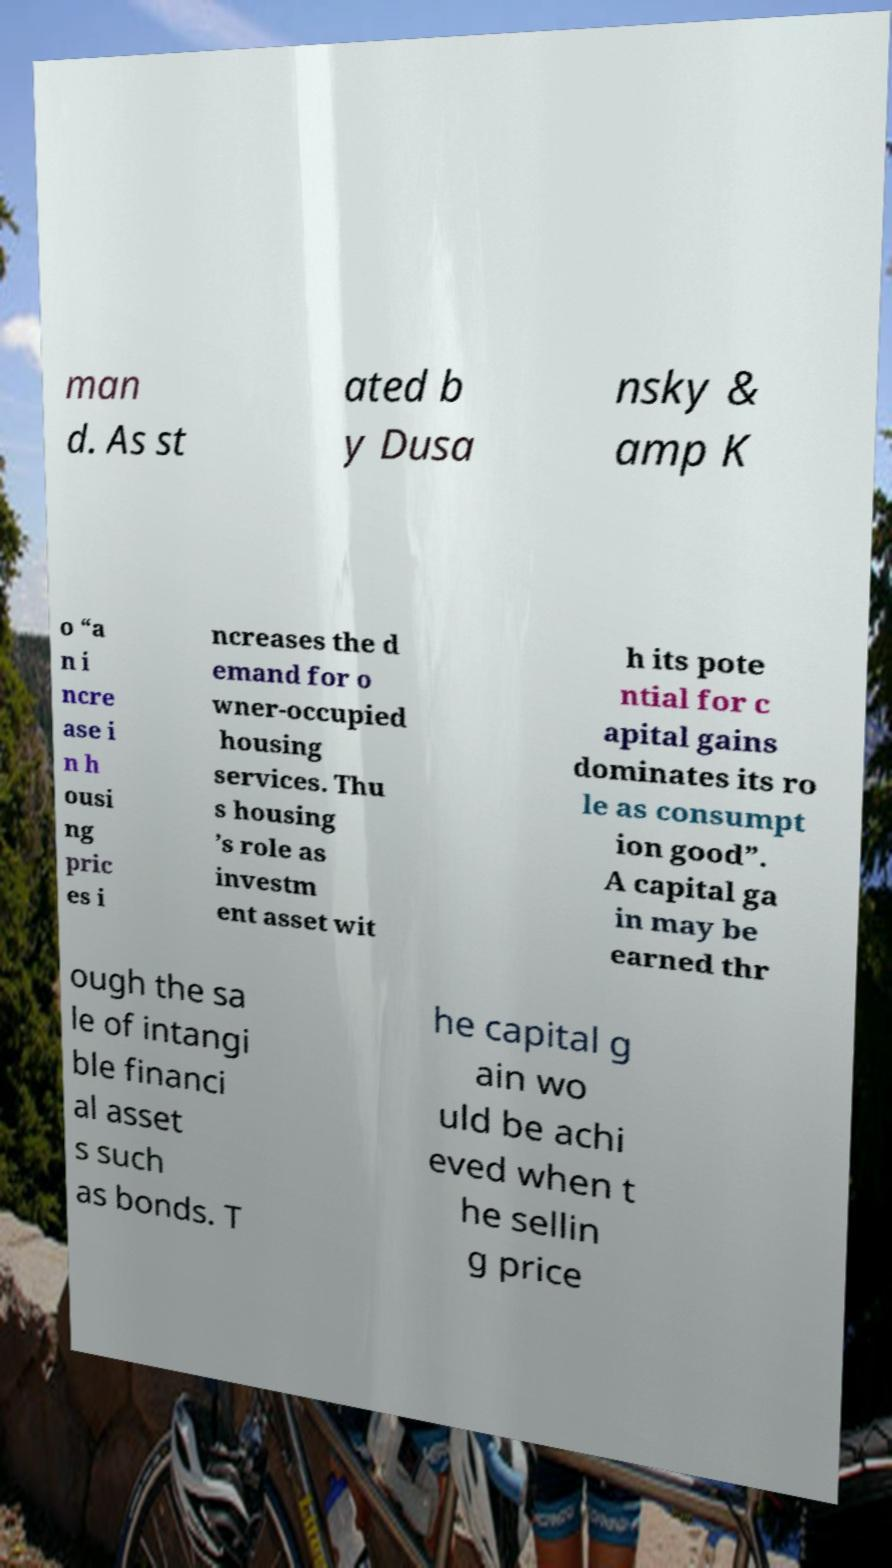For documentation purposes, I need the text within this image transcribed. Could you provide that? man d. As st ated b y Dusa nsky & amp K o “a n i ncre ase i n h ousi ng pric es i ncreases the d emand for o wner-occupied housing services. Thu s housing ’s role as investm ent asset wit h its pote ntial for c apital gains dominates its ro le as consumpt ion good”. A capital ga in may be earned thr ough the sa le of intangi ble financi al asset s such as bonds. T he capital g ain wo uld be achi eved when t he sellin g price 